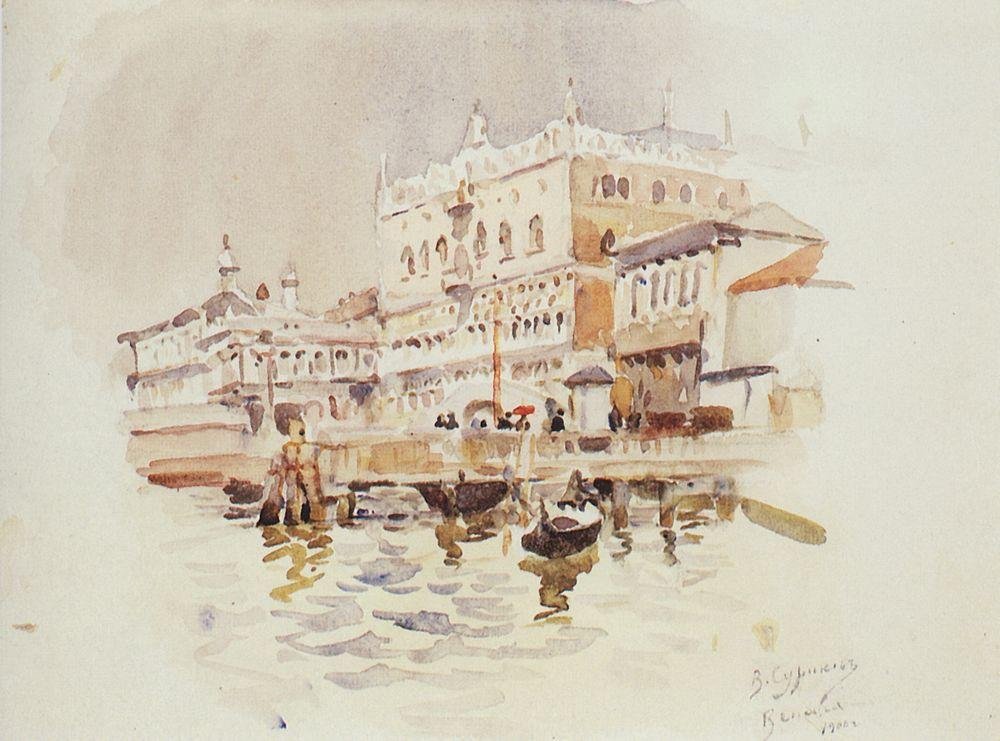What architectural features stand out in this artwork that are typical of Venetian palaces? The artwork highlights several architectural elements typical of Venetian palaces such as ornate balconies, arched windows, and elaborate stonework. These features, combined with the waterfront location, underscore the Gothic and Renaissance influences prevalent in Venetian architecture. 